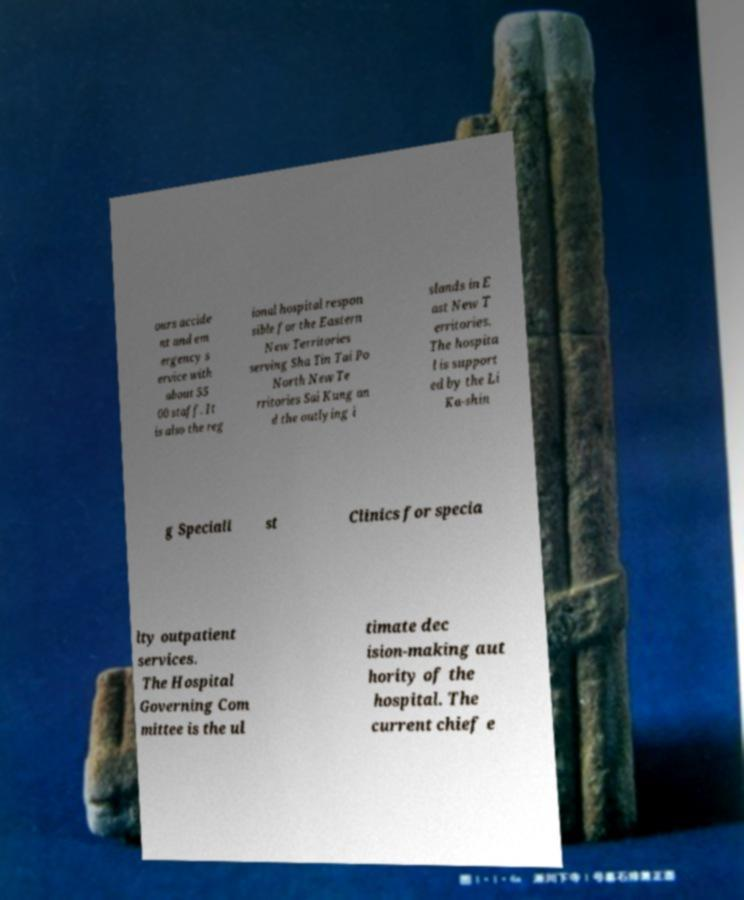Can you read and provide the text displayed in the image?This photo seems to have some interesting text. Can you extract and type it out for me? ours accide nt and em ergency s ervice with about 55 00 staff. It is also the reg ional hospital respon sible for the Eastern New Territories serving Sha Tin Tai Po North New Te rritories Sai Kung an d the outlying i slands in E ast New T erritories. The hospita l is support ed by the Li Ka-shin g Speciali st Clinics for specia lty outpatient services. The Hospital Governing Com mittee is the ul timate dec ision-making aut hority of the hospital. The current chief e 